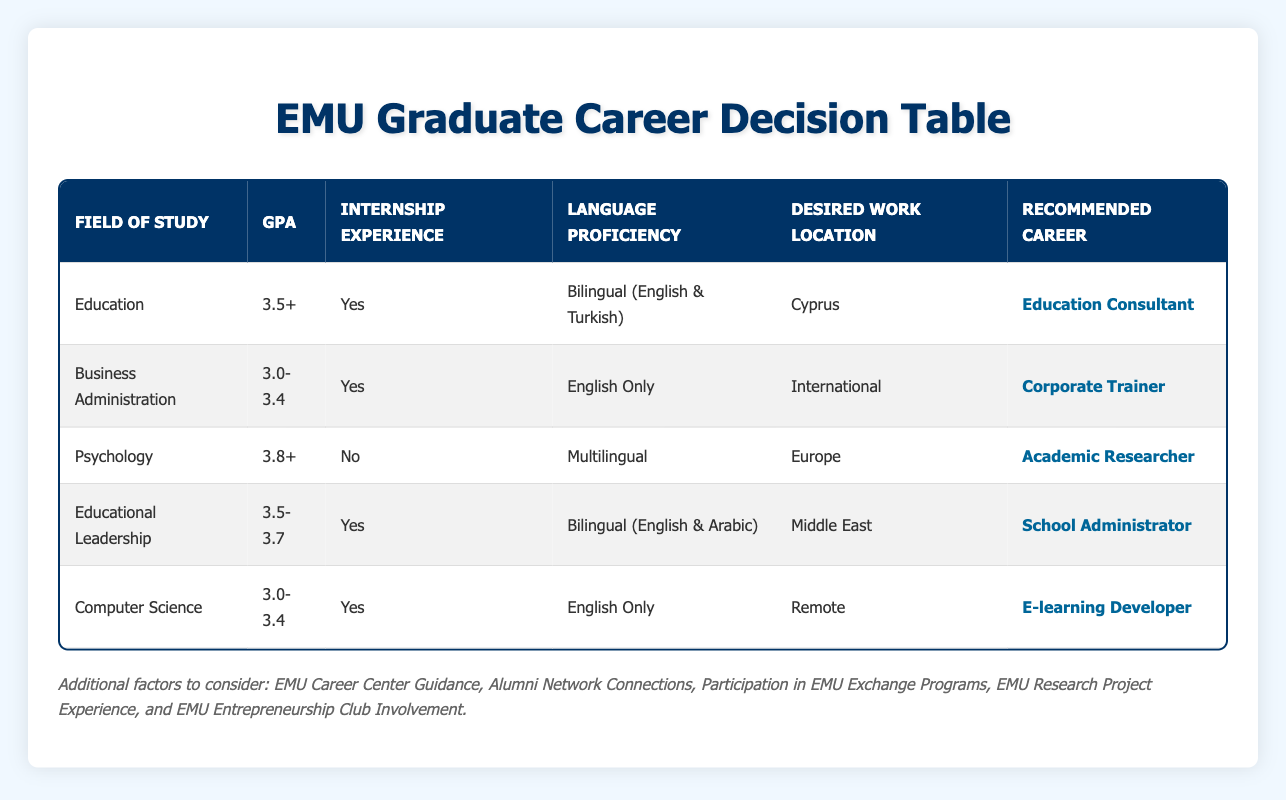What is the recommended career for someone with a GPA of 3.8 or higher? According to the table, a GPA of 3.8+ is associated with the field of Psychology, which recommends a career as an Academic Researcher.
Answer: Academic Researcher How many career options require internship experience? By checking the table, the career options that require internship experience are Education Consultant, Corporate Trainer, School Administrator, and E-learning Developer, totaling four options.
Answer: 4 Does a Bilingual language proficiency guarantee a recommendation for Education Consultant? Yes, the table shows that the recommended career for someone with a Bilingual (English & Turkish) proficiency, studying Education with a GPA of 3.5+, and internship experience is indeed Education Consultant.
Answer: Yes What is the correlation between the field of study Psychology and the recommended career? The table indicates that for graduates in Psychology with a GPA of 3.8+ and no internship experience, the recommended career is Academic Researcher. Therefore, the correlation is that higher education in Psychology leads to a research-oriented career.
Answer: Academic Researcher Which career is recommended for students in Educational Leadership with a GPA between 3.5 and 3.7? According to the table, students in Educational Leadership with a GPA between 3.5 and 3.7 and internship experience are recommended to become a School Administrator.
Answer: School Administrator Are there any careers recommended for those with a GPA lower than 3.0? No, the table does not provide any information on career options for individuals with GPAs lower than 3.0, as all listed recommendations start from a minimum GPA of 3.0.
Answer: No What is the most common desired work location mentioned in the recommendations? The table shows multiple desired work locations: Cyprus, International, Europe, Middle East, and Remote. Cyprus appears as a desired location for Education Consultant, while International pertains to Corporate Trainer, but there is no repetition of desired locations in the recommended careers. Hence, there isn't a common location across all recommendations.
Answer: No common location If a Computer Science graduate has internship experience and speaks English only, what is their recommended career? Based on the table, a Computer Science graduate with a GPA between 3.0 and 3.4, who has internship experience and speaks English only, is recommended to become an E-learning Developer.
Answer: E-learning Developer 